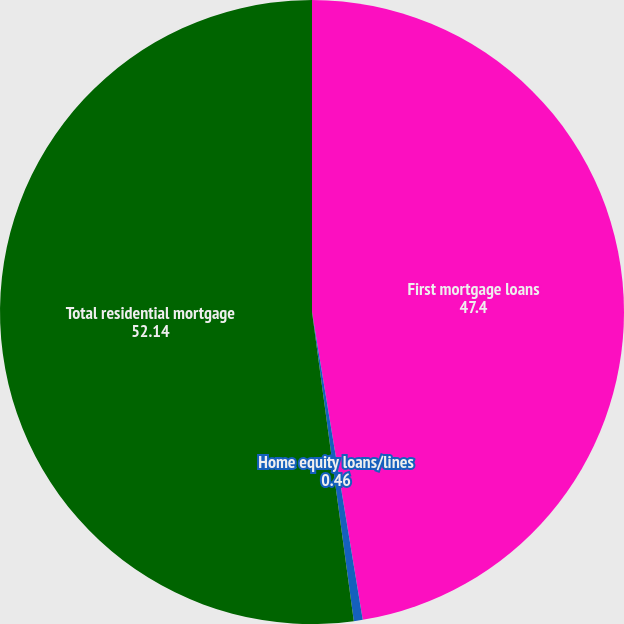Convert chart. <chart><loc_0><loc_0><loc_500><loc_500><pie_chart><fcel>First mortgage loans<fcel>Home equity loans/lines<fcel>Total residential mortgage<nl><fcel>47.4%<fcel>0.46%<fcel>52.14%<nl></chart> 